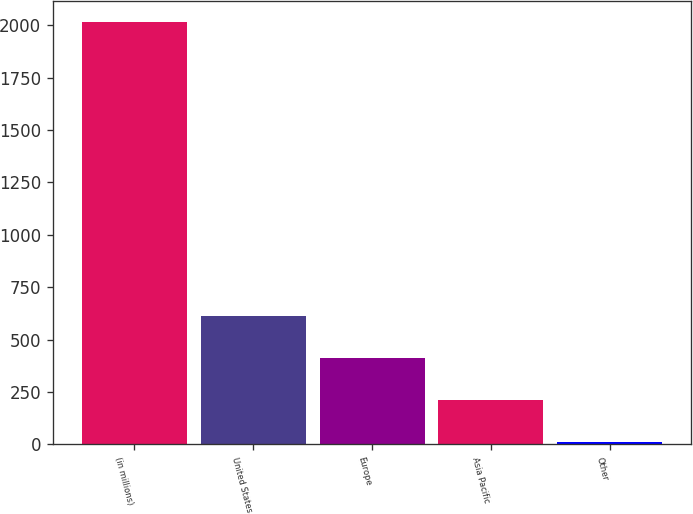<chart> <loc_0><loc_0><loc_500><loc_500><bar_chart><fcel>(in millions)<fcel>United States<fcel>Europe<fcel>Asia Pacific<fcel>Other<nl><fcel>2016<fcel>613.9<fcel>413.6<fcel>213.3<fcel>13<nl></chart> 